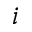Convert formula to latex. <formula><loc_0><loc_0><loc_500><loc_500>i</formula> 